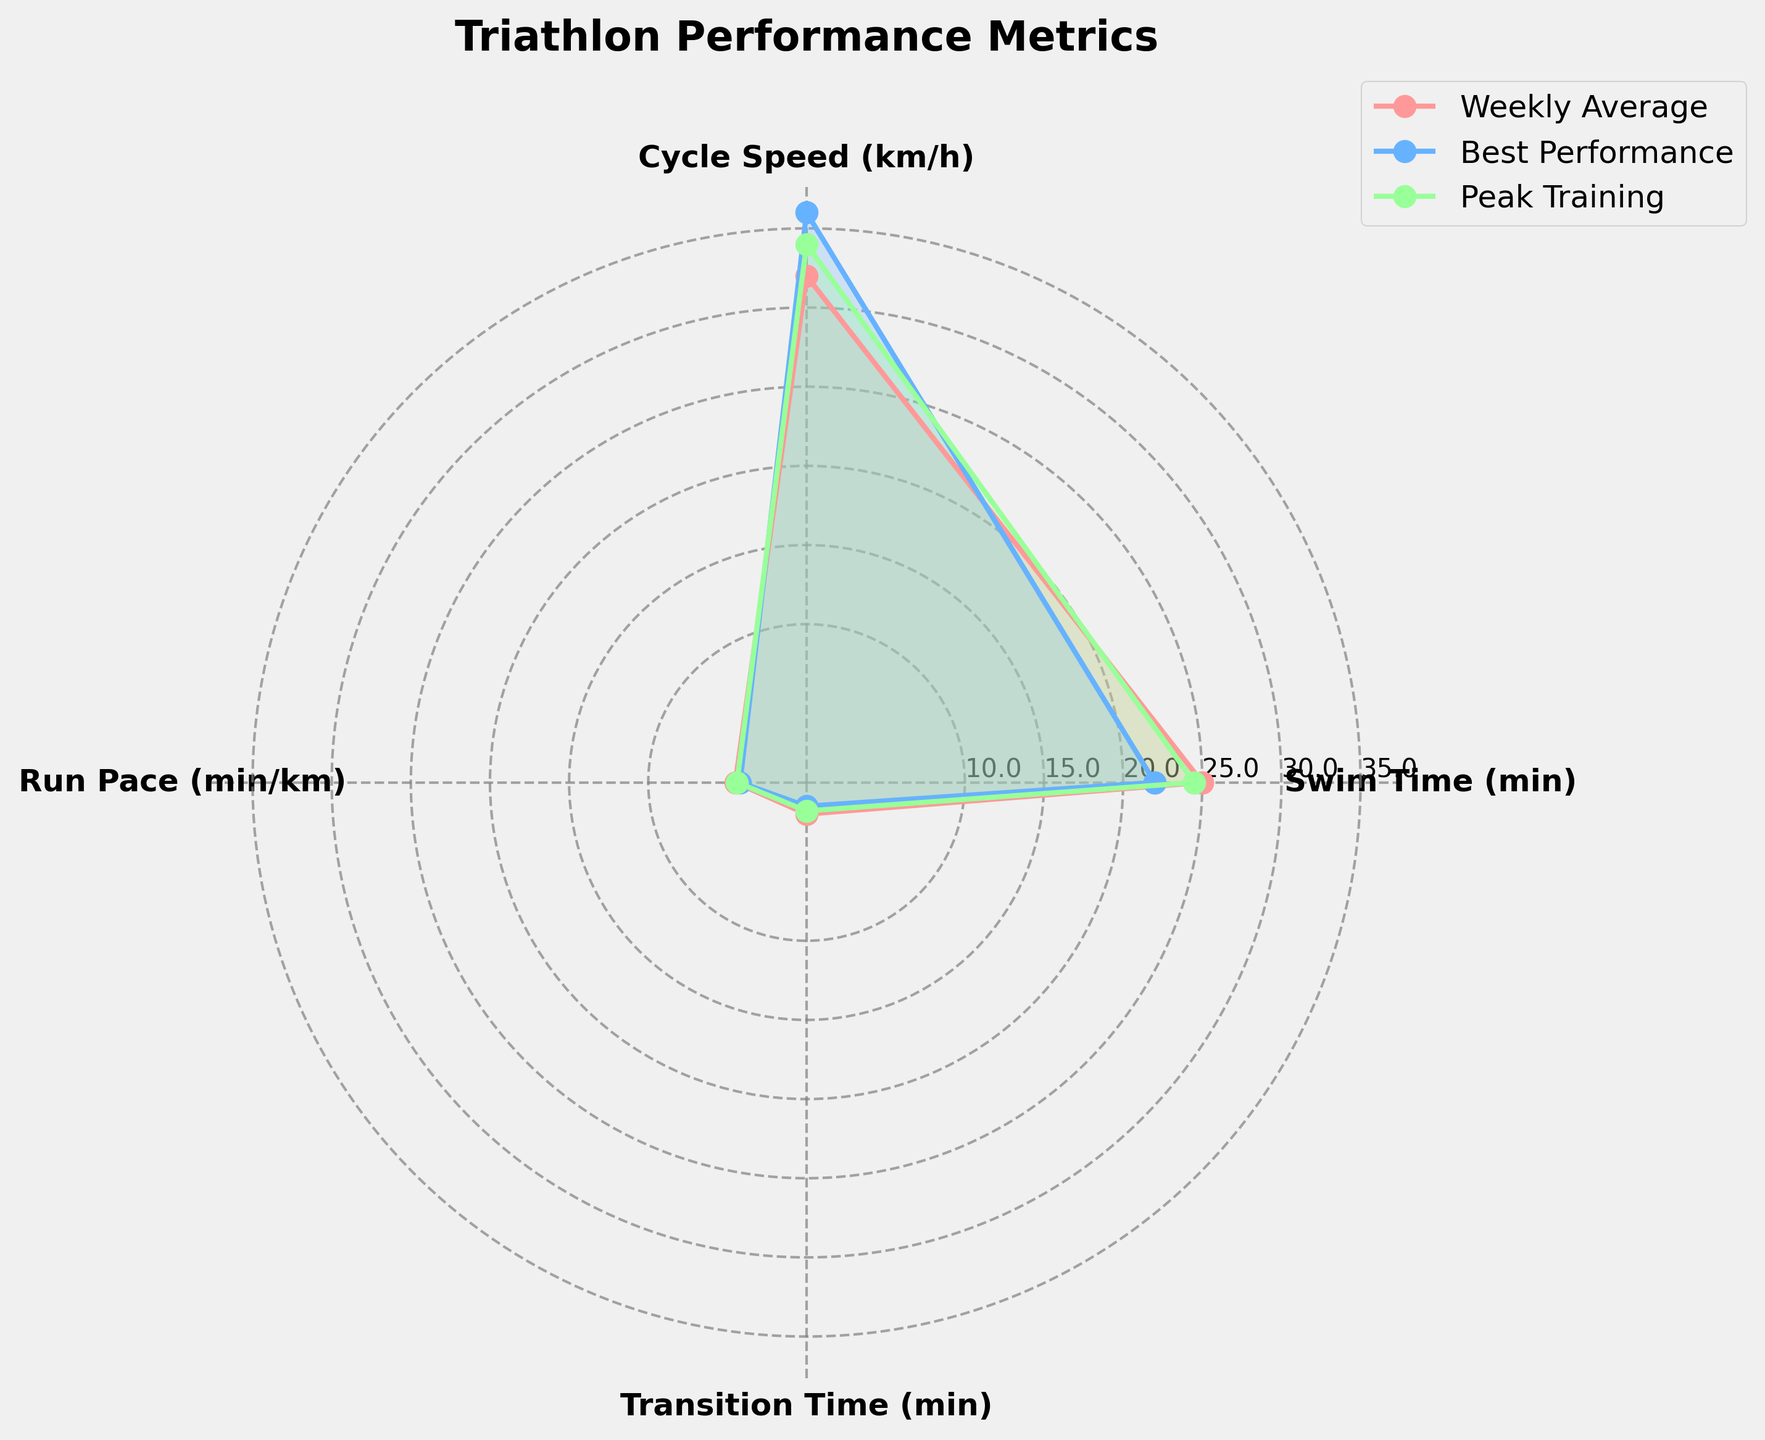What's the title of the chart? The title is usually displayed at the top of the chart. In this case, it's clearly labeled.
Answer: Triathlon Performance Metrics How many groups are represented in the chart? By looking at the legend or different colored areas/lines, we can count the number of groups represented in the chart.
Answer: 3 Which group has the best Swim Time (lowest value)? The Swim Time is indicated on one of the axes. By comparing the positions of the data points closest to the center on that axis, we can determine the group with the best (lowest) Swim Time.
Answer: Best Performance What is the difference in Cycle Speed between Weekly Average and Peak Training? Locate the Cycle Speed positions for both groups on the relevant axis and subtract the values (Peak Training Cycle Speed - Weekly Average Cycle Speed).
Answer: 2 km/h Between which two metrics does Weekly Average show the biggest difference? Examine the Weekly Average data points and check the distances between each pair of metrics. The largest difference will indicate where the greatest change occurs.
Answer: Swim Time and Run Pace Which metric has the least variation among the groups? Look at each metric's variation by checking how close the data points are to each other across the groups. The metric with the least spread has the least variation.
Answer: Transition Time What's the average Cycle Speed across all three groups? Add the Cycle Speed values for Weekly Average (32), Best Performance (36), and Peak Training (34), then divide by the number of groups (3).
Answer: 34 km/h In terms of Run Pace, which group performs better, Best Performance or Peak Training? The Run Pace metric's axis will show the positions for both groups. Since a lower Run Pace indicates a better performance, compare the values directly.
Answer: Best Performance How much faster is the Best Performance group's Swim Time compared to the Post-Recovery group's Swim Time? Find and subtract the Swim Time value for Best Performance from the Swim Time value for Post-Recovery (Post-Recovery Swim Time - Best Performance Swim Time).
Answer: 5 minutes Which group has the closest values in Swim Time and Transition Time? Compare the Swim Time and Transition Time values for each group. Identify which group has the least difference between these two metrics.
Answer: Best Performance 